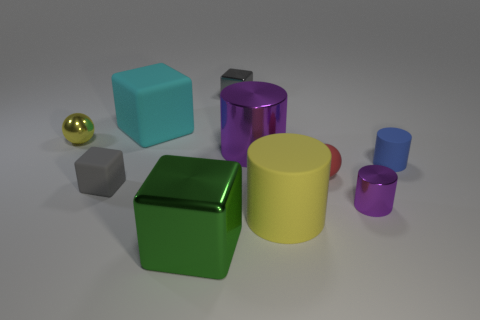There is a thing that is the same color as the small metallic ball; what is its size?
Offer a very short reply. Large. What size is the ball that is made of the same material as the blue cylinder?
Your answer should be compact. Small. How many objects are either large objects that are to the right of the tiny gray shiny object or gray objects behind the green thing?
Give a very brief answer. 4. Are there the same number of large purple shiny cylinders that are in front of the red ball and big yellow things to the left of the small gray metallic cube?
Make the answer very short. Yes. There is a metallic cylinder on the left side of the tiny red rubber thing; what is its color?
Your answer should be compact. Purple. Does the matte ball have the same color as the large matte cylinder that is to the right of the metal sphere?
Provide a succinct answer. No. Is the number of small metallic things less than the number of brown rubber cubes?
Provide a succinct answer. No. There is a big metal thing behind the green shiny cube; does it have the same color as the tiny shiny cylinder?
Give a very brief answer. Yes. How many blue matte cylinders are the same size as the cyan block?
Keep it short and to the point. 0. Is there a rubber cylinder of the same color as the matte sphere?
Your answer should be very brief. No. 